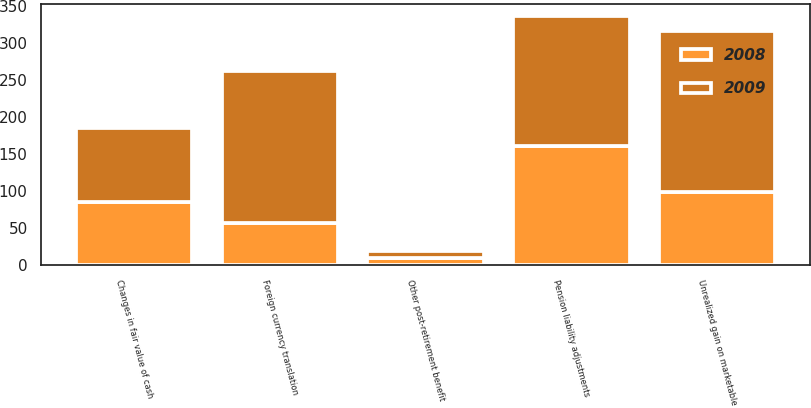Convert chart to OTSL. <chart><loc_0><loc_0><loc_500><loc_500><stacked_bar_chart><ecel><fcel>Unrealized gain on marketable<fcel>Foreign currency translation<fcel>Pension liability adjustments<fcel>Other post-retirement benefit<fcel>Changes in fair value of cash<nl><fcel>2008<fcel>99<fcel>57<fcel>161<fcel>9<fcel>86<nl><fcel>2009<fcel>218<fcel>206<fcel>176<fcel>10<fcel>99<nl></chart> 